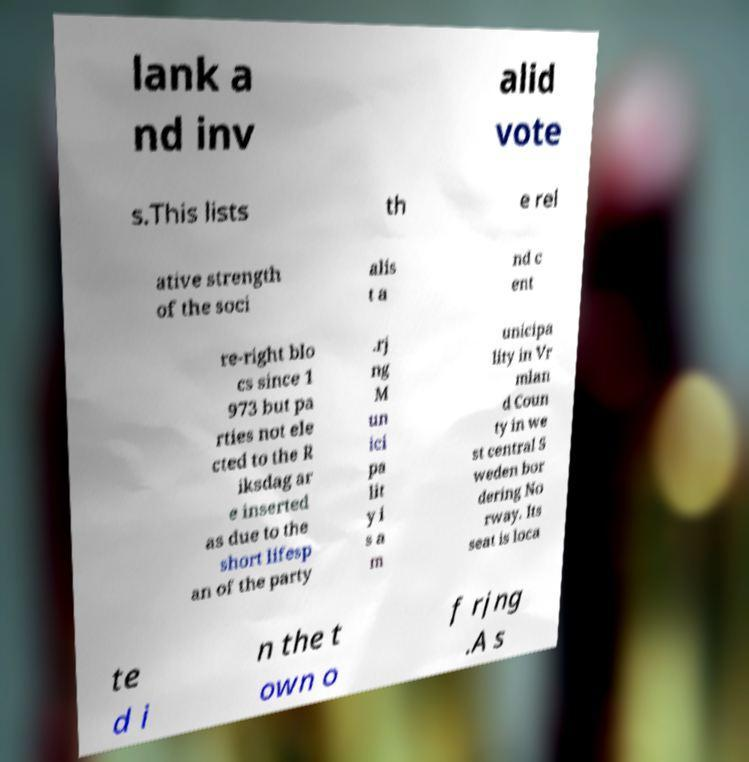There's text embedded in this image that I need extracted. Can you transcribe it verbatim? lank a nd inv alid vote s.This lists th e rel ative strength of the soci alis t a nd c ent re-right blo cs since 1 973 but pa rties not ele cted to the R iksdag ar e inserted as due to the short lifesp an of the party .rj ng M un ici pa lit y i s a m unicipa lity in Vr mlan d Coun ty in we st central S weden bor dering No rway. Its seat is loca te d i n the t own o f rjng .A s 